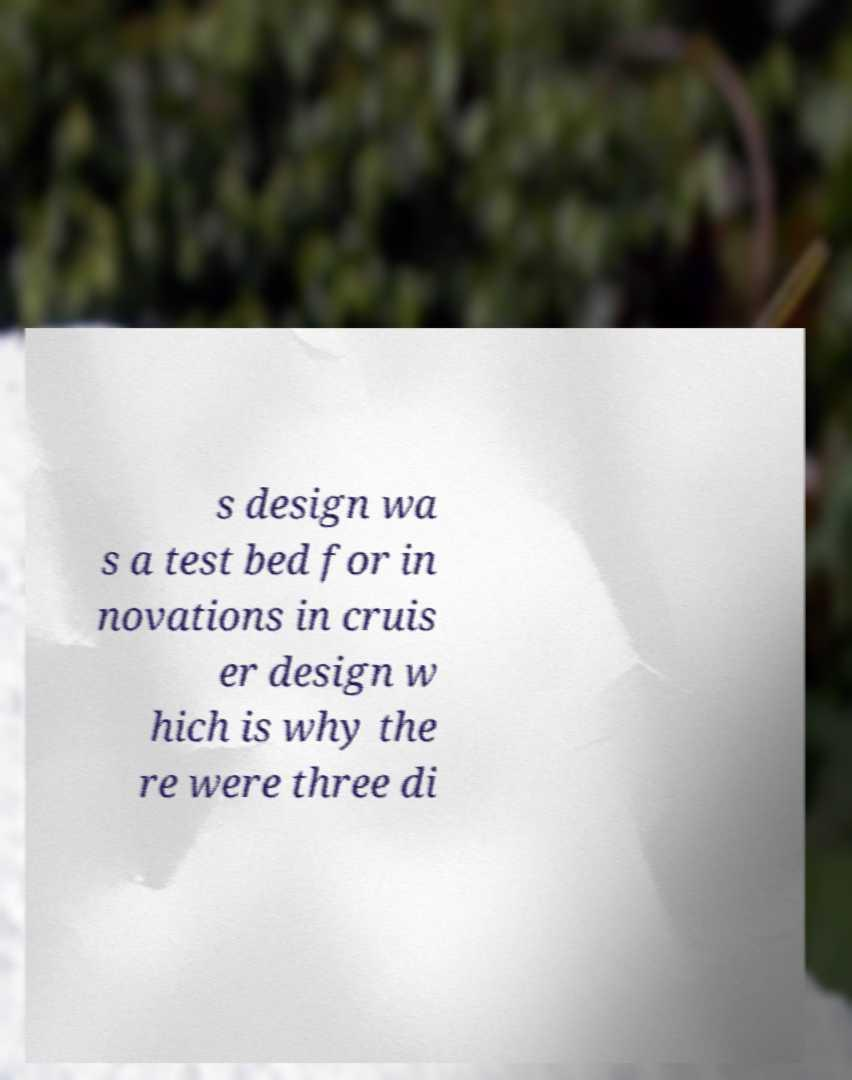Can you read and provide the text displayed in the image?This photo seems to have some interesting text. Can you extract and type it out for me? s design wa s a test bed for in novations in cruis er design w hich is why the re were three di 